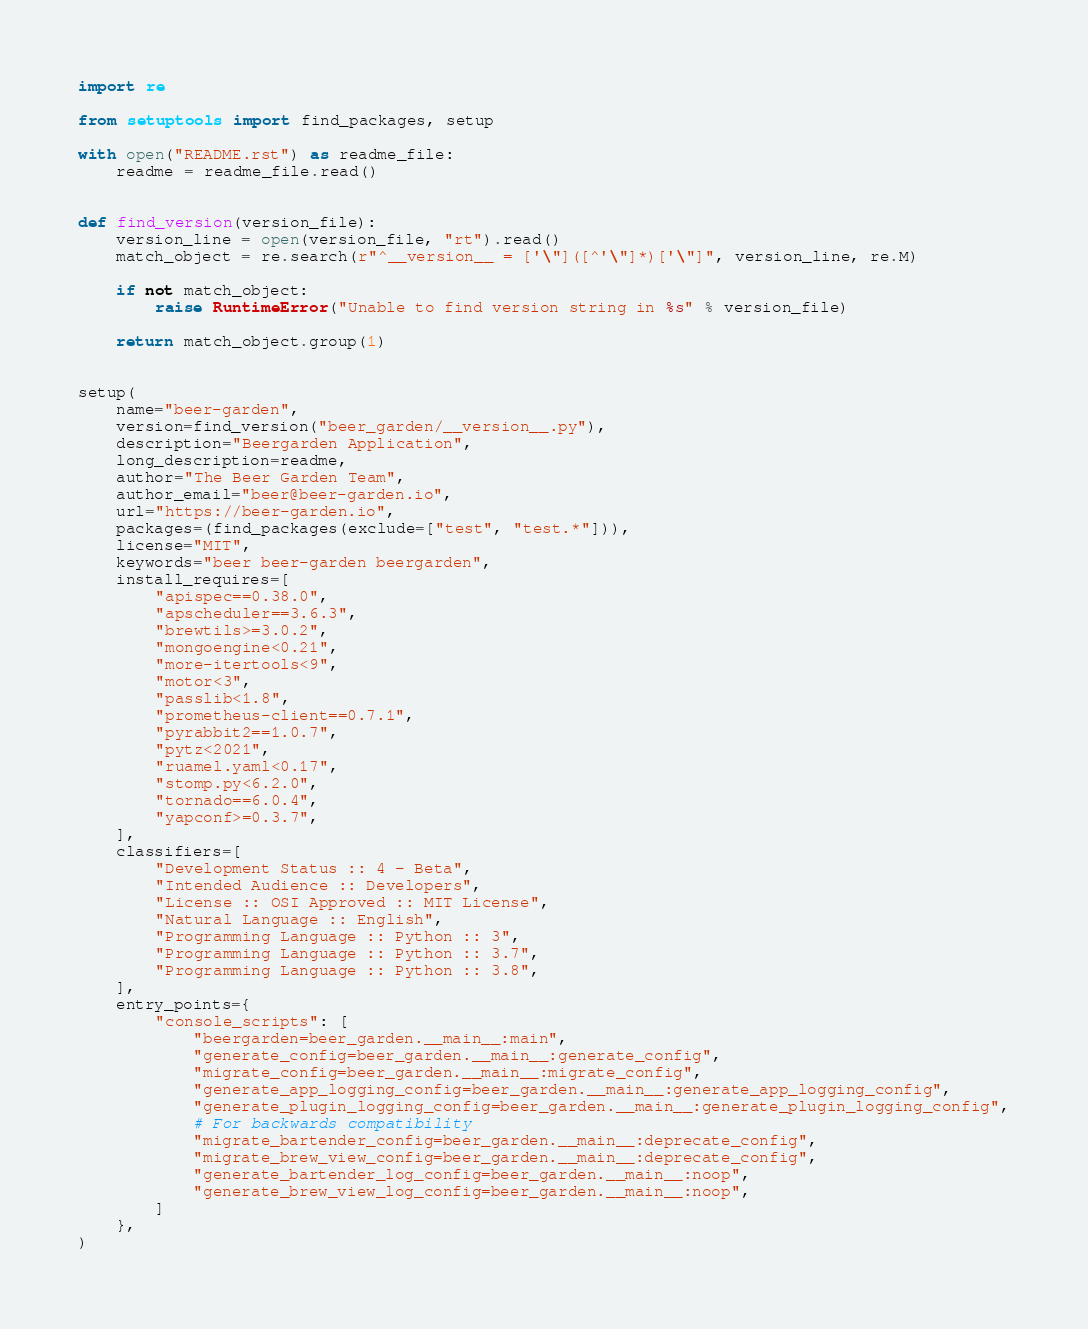Convert code to text. <code><loc_0><loc_0><loc_500><loc_500><_Python_>import re

from setuptools import find_packages, setup

with open("README.rst") as readme_file:
    readme = readme_file.read()


def find_version(version_file):
    version_line = open(version_file, "rt").read()
    match_object = re.search(r"^__version__ = ['\"]([^'\"]*)['\"]", version_line, re.M)

    if not match_object:
        raise RuntimeError("Unable to find version string in %s" % version_file)

    return match_object.group(1)


setup(
    name="beer-garden",
    version=find_version("beer_garden/__version__.py"),
    description="Beergarden Application",
    long_description=readme,
    author="The Beer Garden Team",
    author_email="beer@beer-garden.io",
    url="https://beer-garden.io",
    packages=(find_packages(exclude=["test", "test.*"])),
    license="MIT",
    keywords="beer beer-garden beergarden",
    install_requires=[
        "apispec==0.38.0",
        "apscheduler==3.6.3",
        "brewtils>=3.0.2",
        "mongoengine<0.21",
        "more-itertools<9",
        "motor<3",
        "passlib<1.8",
        "prometheus-client==0.7.1",
        "pyrabbit2==1.0.7",
        "pytz<2021",
        "ruamel.yaml<0.17",
        "stomp.py<6.2.0",
        "tornado==6.0.4",
        "yapconf>=0.3.7",
    ],
    classifiers=[
        "Development Status :: 4 - Beta",
        "Intended Audience :: Developers",
        "License :: OSI Approved :: MIT License",
        "Natural Language :: English",
        "Programming Language :: Python :: 3",
        "Programming Language :: Python :: 3.7",
        "Programming Language :: Python :: 3.8",
    ],
    entry_points={
        "console_scripts": [
            "beergarden=beer_garden.__main__:main",
            "generate_config=beer_garden.__main__:generate_config",
            "migrate_config=beer_garden.__main__:migrate_config",
            "generate_app_logging_config=beer_garden.__main__:generate_app_logging_config",
            "generate_plugin_logging_config=beer_garden.__main__:generate_plugin_logging_config",
            # For backwards compatibility
            "migrate_bartender_config=beer_garden.__main__:deprecate_config",
            "migrate_brew_view_config=beer_garden.__main__:deprecate_config",
            "generate_bartender_log_config=beer_garden.__main__:noop",
            "generate_brew_view_log_config=beer_garden.__main__:noop",
        ]
    },
)
</code> 